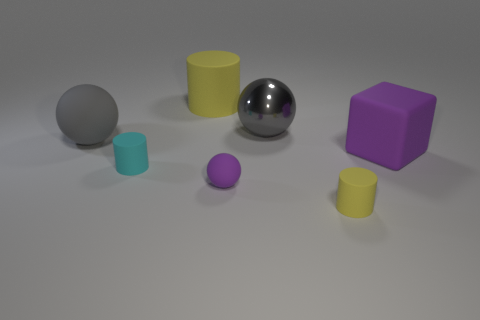Do the gray object that is right of the small cyan cylinder and the tiny purple ball have the same material?
Keep it short and to the point. No. There is a big gray sphere right of the yellow rubber cylinder that is behind the matte block; how many big matte things are in front of it?
Keep it short and to the point. 2. There is a yellow object behind the purple rubber ball; does it have the same shape as the small purple matte thing?
Offer a very short reply. No. How many things are either tiny spheres or small things that are behind the small rubber ball?
Make the answer very short. 2. Are there more large cylinders that are behind the big gray shiny thing than big purple cylinders?
Provide a succinct answer. Yes. Is the number of small yellow cylinders behind the metal thing the same as the number of yellow cylinders that are in front of the big gray matte ball?
Provide a succinct answer. No. Are there any rubber cylinders in front of the yellow matte cylinder in front of the block?
Offer a very short reply. No. There is a large purple rubber thing; what shape is it?
Your response must be concise. Cube. There is a rubber thing that is the same color as the cube; what size is it?
Your answer should be very brief. Small. There is a matte cylinder that is behind the cyan matte cylinder that is in front of the big purple rubber thing; what size is it?
Keep it short and to the point. Large. 